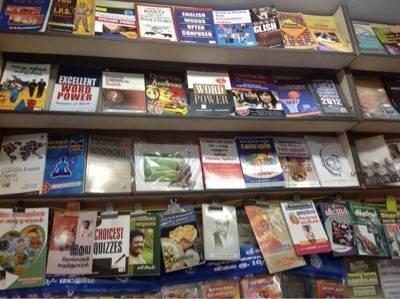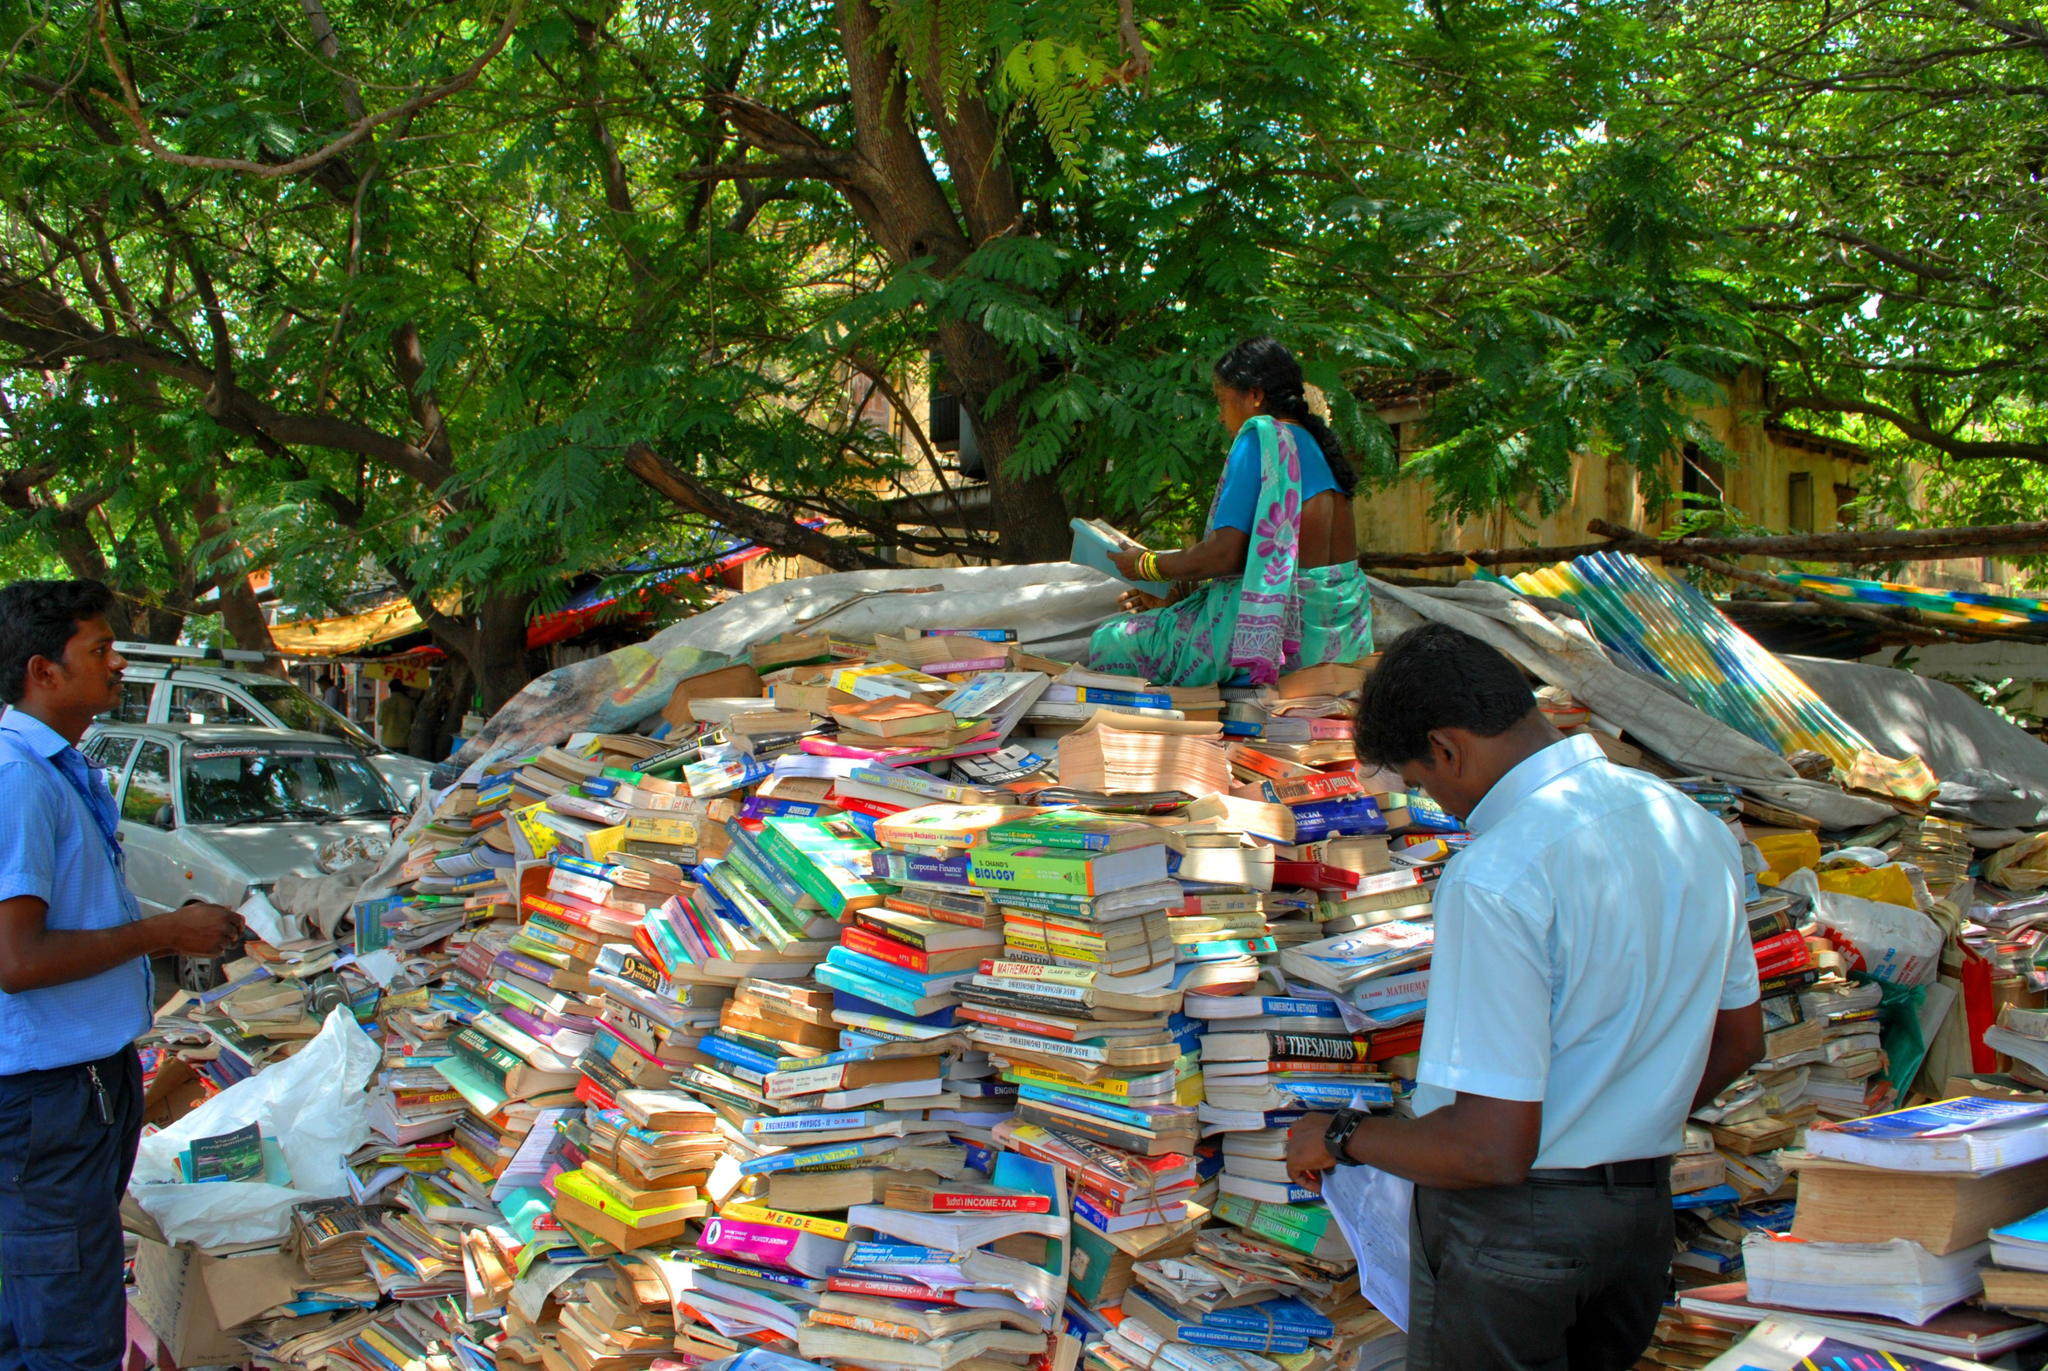The first image is the image on the left, the second image is the image on the right. Assess this claim about the two images: "In the book store there are at least 10 stuff bears ranging in color from pink, orange and purple sit on the top back self.". Correct or not? Answer yes or no. No. 